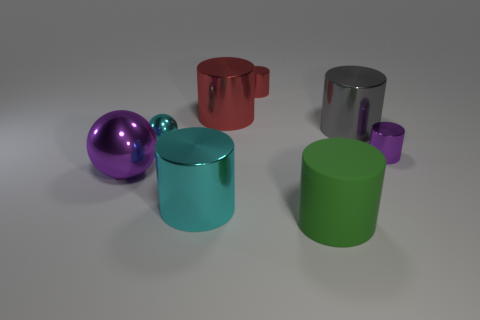What is the small object that is both in front of the gray metallic cylinder and on the right side of the tiny metallic ball made of?
Your answer should be compact. Metal. What is the material of the purple thing that is to the right of the green object?
Give a very brief answer. Metal. The other large ball that is the same material as the cyan sphere is what color?
Give a very brief answer. Purple. Do the large green matte object and the purple object on the right side of the big green cylinder have the same shape?
Offer a terse response. Yes. Are there any red metallic things in front of the big green thing?
Give a very brief answer. No. What material is the cylinder that is the same color as the tiny sphere?
Provide a short and direct response. Metal. There is a green object; does it have the same size as the purple shiny object that is on the left side of the purple shiny cylinder?
Provide a succinct answer. Yes. Are there any large shiny spheres that have the same color as the big matte thing?
Provide a short and direct response. No. Are there any tiny brown matte objects that have the same shape as the green object?
Your answer should be compact. No. What is the shape of the tiny object that is both behind the small purple shiny object and in front of the big gray shiny thing?
Ensure brevity in your answer.  Sphere. 